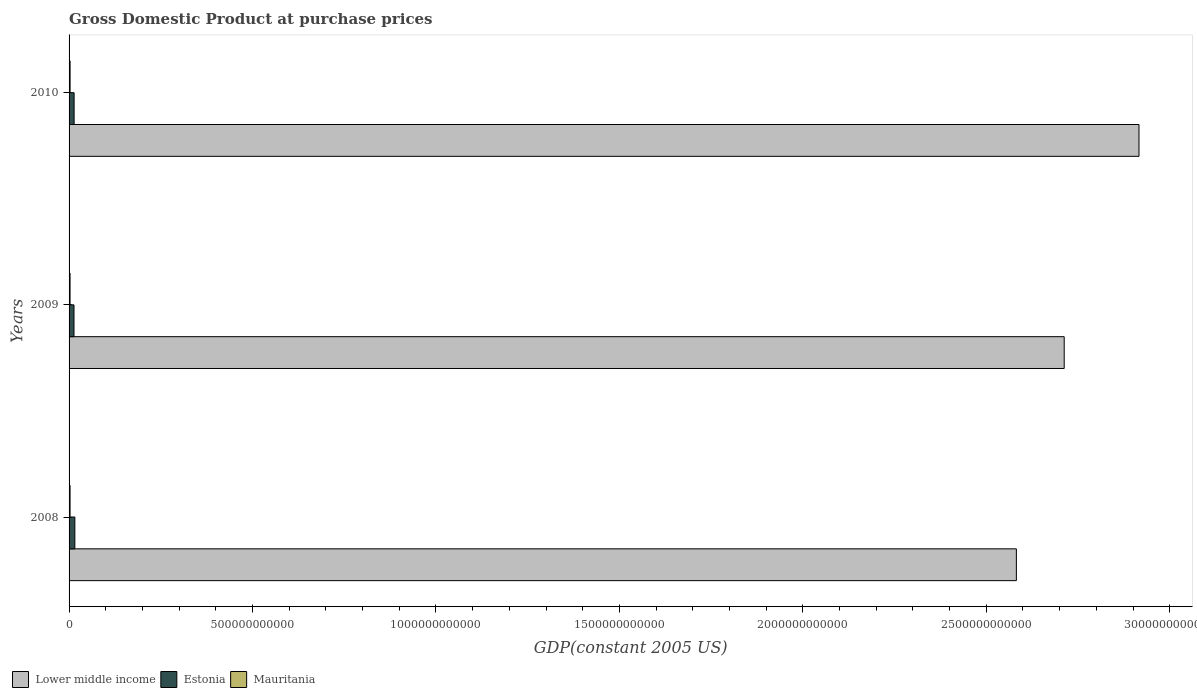How many groups of bars are there?
Provide a short and direct response. 3. Are the number of bars per tick equal to the number of legend labels?
Offer a terse response. Yes. Are the number of bars on each tick of the Y-axis equal?
Make the answer very short. Yes. How many bars are there on the 2nd tick from the top?
Keep it short and to the point. 3. How many bars are there on the 3rd tick from the bottom?
Offer a terse response. 3. In how many cases, is the number of bars for a given year not equal to the number of legend labels?
Offer a terse response. 0. What is the GDP at purchase prices in Estonia in 2008?
Give a very brief answer. 1.57e+1. Across all years, what is the maximum GDP at purchase prices in Estonia?
Make the answer very short. 1.57e+1. Across all years, what is the minimum GDP at purchase prices in Mauritania?
Your response must be concise. 2.67e+09. In which year was the GDP at purchase prices in Mauritania maximum?
Provide a short and direct response. 2010. In which year was the GDP at purchase prices in Mauritania minimum?
Give a very brief answer. 2009. What is the total GDP at purchase prices in Estonia in the graph?
Keep it short and to the point. 4.29e+1. What is the difference between the GDP at purchase prices in Estonia in 2008 and that in 2009?
Offer a terse response. 2.32e+09. What is the difference between the GDP at purchase prices in Mauritania in 2010 and the GDP at purchase prices in Lower middle income in 2009?
Give a very brief answer. -2.71e+12. What is the average GDP at purchase prices in Estonia per year?
Your answer should be very brief. 1.43e+1. In the year 2009, what is the difference between the GDP at purchase prices in Lower middle income and GDP at purchase prices in Mauritania?
Provide a short and direct response. 2.71e+12. What is the ratio of the GDP at purchase prices in Mauritania in 2008 to that in 2009?
Provide a short and direct response. 1.01. What is the difference between the highest and the second highest GDP at purchase prices in Mauritania?
Provide a succinct answer. 9.94e+07. What is the difference between the highest and the lowest GDP at purchase prices in Estonia?
Offer a very short reply. 2.32e+09. In how many years, is the GDP at purchase prices in Lower middle income greater than the average GDP at purchase prices in Lower middle income taken over all years?
Provide a short and direct response. 1. What does the 3rd bar from the top in 2010 represents?
Keep it short and to the point. Lower middle income. What does the 1st bar from the bottom in 2009 represents?
Give a very brief answer. Lower middle income. What is the difference between two consecutive major ticks on the X-axis?
Provide a short and direct response. 5.00e+11. What is the title of the graph?
Keep it short and to the point. Gross Domestic Product at purchase prices. What is the label or title of the X-axis?
Give a very brief answer. GDP(constant 2005 US). What is the label or title of the Y-axis?
Make the answer very short. Years. What is the GDP(constant 2005 US) in Lower middle income in 2008?
Offer a terse response. 2.58e+12. What is the GDP(constant 2005 US) of Estonia in 2008?
Your response must be concise. 1.57e+1. What is the GDP(constant 2005 US) in Mauritania in 2008?
Provide a short and direct response. 2.70e+09. What is the GDP(constant 2005 US) of Lower middle income in 2009?
Your answer should be very brief. 2.71e+12. What is the GDP(constant 2005 US) of Estonia in 2009?
Your answer should be compact. 1.34e+1. What is the GDP(constant 2005 US) in Mauritania in 2009?
Your response must be concise. 2.67e+09. What is the GDP(constant 2005 US) of Lower middle income in 2010?
Ensure brevity in your answer.  2.92e+12. What is the GDP(constant 2005 US) in Estonia in 2010?
Your answer should be compact. 1.38e+1. What is the GDP(constant 2005 US) of Mauritania in 2010?
Provide a succinct answer. 2.80e+09. Across all years, what is the maximum GDP(constant 2005 US) in Lower middle income?
Provide a short and direct response. 2.92e+12. Across all years, what is the maximum GDP(constant 2005 US) in Estonia?
Give a very brief answer. 1.57e+1. Across all years, what is the maximum GDP(constant 2005 US) of Mauritania?
Make the answer very short. 2.80e+09. Across all years, what is the minimum GDP(constant 2005 US) of Lower middle income?
Your answer should be very brief. 2.58e+12. Across all years, what is the minimum GDP(constant 2005 US) of Estonia?
Your answer should be very brief. 1.34e+1. Across all years, what is the minimum GDP(constant 2005 US) in Mauritania?
Offer a terse response. 2.67e+09. What is the total GDP(constant 2005 US) of Lower middle income in the graph?
Provide a short and direct response. 8.21e+12. What is the total GDP(constant 2005 US) in Estonia in the graph?
Keep it short and to the point. 4.29e+1. What is the total GDP(constant 2005 US) of Mauritania in the graph?
Keep it short and to the point. 8.17e+09. What is the difference between the GDP(constant 2005 US) of Lower middle income in 2008 and that in 2009?
Provide a succinct answer. -1.30e+11. What is the difference between the GDP(constant 2005 US) of Estonia in 2008 and that in 2009?
Offer a terse response. 2.32e+09. What is the difference between the GDP(constant 2005 US) in Mauritania in 2008 and that in 2009?
Make the answer very short. 2.81e+07. What is the difference between the GDP(constant 2005 US) in Lower middle income in 2008 and that in 2010?
Your response must be concise. -3.34e+11. What is the difference between the GDP(constant 2005 US) of Estonia in 2008 and that in 2010?
Offer a terse response. 1.99e+09. What is the difference between the GDP(constant 2005 US) of Mauritania in 2008 and that in 2010?
Keep it short and to the point. -9.94e+07. What is the difference between the GDP(constant 2005 US) in Lower middle income in 2009 and that in 2010?
Your answer should be compact. -2.04e+11. What is the difference between the GDP(constant 2005 US) of Estonia in 2009 and that in 2010?
Make the answer very short. -3.31e+08. What is the difference between the GDP(constant 2005 US) in Mauritania in 2009 and that in 2010?
Give a very brief answer. -1.27e+08. What is the difference between the GDP(constant 2005 US) of Lower middle income in 2008 and the GDP(constant 2005 US) of Estonia in 2009?
Keep it short and to the point. 2.57e+12. What is the difference between the GDP(constant 2005 US) in Lower middle income in 2008 and the GDP(constant 2005 US) in Mauritania in 2009?
Your answer should be compact. 2.58e+12. What is the difference between the GDP(constant 2005 US) of Estonia in 2008 and the GDP(constant 2005 US) of Mauritania in 2009?
Ensure brevity in your answer.  1.31e+1. What is the difference between the GDP(constant 2005 US) of Lower middle income in 2008 and the GDP(constant 2005 US) of Estonia in 2010?
Provide a succinct answer. 2.57e+12. What is the difference between the GDP(constant 2005 US) in Lower middle income in 2008 and the GDP(constant 2005 US) in Mauritania in 2010?
Offer a very short reply. 2.58e+12. What is the difference between the GDP(constant 2005 US) of Estonia in 2008 and the GDP(constant 2005 US) of Mauritania in 2010?
Provide a succinct answer. 1.29e+1. What is the difference between the GDP(constant 2005 US) of Lower middle income in 2009 and the GDP(constant 2005 US) of Estonia in 2010?
Keep it short and to the point. 2.70e+12. What is the difference between the GDP(constant 2005 US) in Lower middle income in 2009 and the GDP(constant 2005 US) in Mauritania in 2010?
Ensure brevity in your answer.  2.71e+12. What is the difference between the GDP(constant 2005 US) in Estonia in 2009 and the GDP(constant 2005 US) in Mauritania in 2010?
Provide a succinct answer. 1.06e+1. What is the average GDP(constant 2005 US) in Lower middle income per year?
Offer a very short reply. 2.74e+12. What is the average GDP(constant 2005 US) of Estonia per year?
Ensure brevity in your answer.  1.43e+1. What is the average GDP(constant 2005 US) of Mauritania per year?
Your answer should be very brief. 2.72e+09. In the year 2008, what is the difference between the GDP(constant 2005 US) in Lower middle income and GDP(constant 2005 US) in Estonia?
Your answer should be compact. 2.57e+12. In the year 2008, what is the difference between the GDP(constant 2005 US) in Lower middle income and GDP(constant 2005 US) in Mauritania?
Keep it short and to the point. 2.58e+12. In the year 2008, what is the difference between the GDP(constant 2005 US) of Estonia and GDP(constant 2005 US) of Mauritania?
Your answer should be compact. 1.30e+1. In the year 2009, what is the difference between the GDP(constant 2005 US) of Lower middle income and GDP(constant 2005 US) of Estonia?
Keep it short and to the point. 2.70e+12. In the year 2009, what is the difference between the GDP(constant 2005 US) of Lower middle income and GDP(constant 2005 US) of Mauritania?
Provide a succinct answer. 2.71e+12. In the year 2009, what is the difference between the GDP(constant 2005 US) of Estonia and GDP(constant 2005 US) of Mauritania?
Provide a short and direct response. 1.08e+1. In the year 2010, what is the difference between the GDP(constant 2005 US) in Lower middle income and GDP(constant 2005 US) in Estonia?
Offer a terse response. 2.90e+12. In the year 2010, what is the difference between the GDP(constant 2005 US) of Lower middle income and GDP(constant 2005 US) of Mauritania?
Offer a terse response. 2.91e+12. In the year 2010, what is the difference between the GDP(constant 2005 US) of Estonia and GDP(constant 2005 US) of Mauritania?
Provide a succinct answer. 1.10e+1. What is the ratio of the GDP(constant 2005 US) in Lower middle income in 2008 to that in 2009?
Make the answer very short. 0.95. What is the ratio of the GDP(constant 2005 US) of Estonia in 2008 to that in 2009?
Offer a terse response. 1.17. What is the ratio of the GDP(constant 2005 US) in Mauritania in 2008 to that in 2009?
Provide a succinct answer. 1.01. What is the ratio of the GDP(constant 2005 US) of Lower middle income in 2008 to that in 2010?
Your answer should be very brief. 0.89. What is the ratio of the GDP(constant 2005 US) of Estonia in 2008 to that in 2010?
Provide a short and direct response. 1.14. What is the ratio of the GDP(constant 2005 US) in Mauritania in 2008 to that in 2010?
Provide a short and direct response. 0.96. What is the ratio of the GDP(constant 2005 US) of Lower middle income in 2009 to that in 2010?
Your answer should be compact. 0.93. What is the ratio of the GDP(constant 2005 US) of Mauritania in 2009 to that in 2010?
Make the answer very short. 0.95. What is the difference between the highest and the second highest GDP(constant 2005 US) of Lower middle income?
Offer a terse response. 2.04e+11. What is the difference between the highest and the second highest GDP(constant 2005 US) in Estonia?
Give a very brief answer. 1.99e+09. What is the difference between the highest and the second highest GDP(constant 2005 US) in Mauritania?
Your answer should be compact. 9.94e+07. What is the difference between the highest and the lowest GDP(constant 2005 US) of Lower middle income?
Your response must be concise. 3.34e+11. What is the difference between the highest and the lowest GDP(constant 2005 US) of Estonia?
Provide a short and direct response. 2.32e+09. What is the difference between the highest and the lowest GDP(constant 2005 US) of Mauritania?
Offer a terse response. 1.27e+08. 